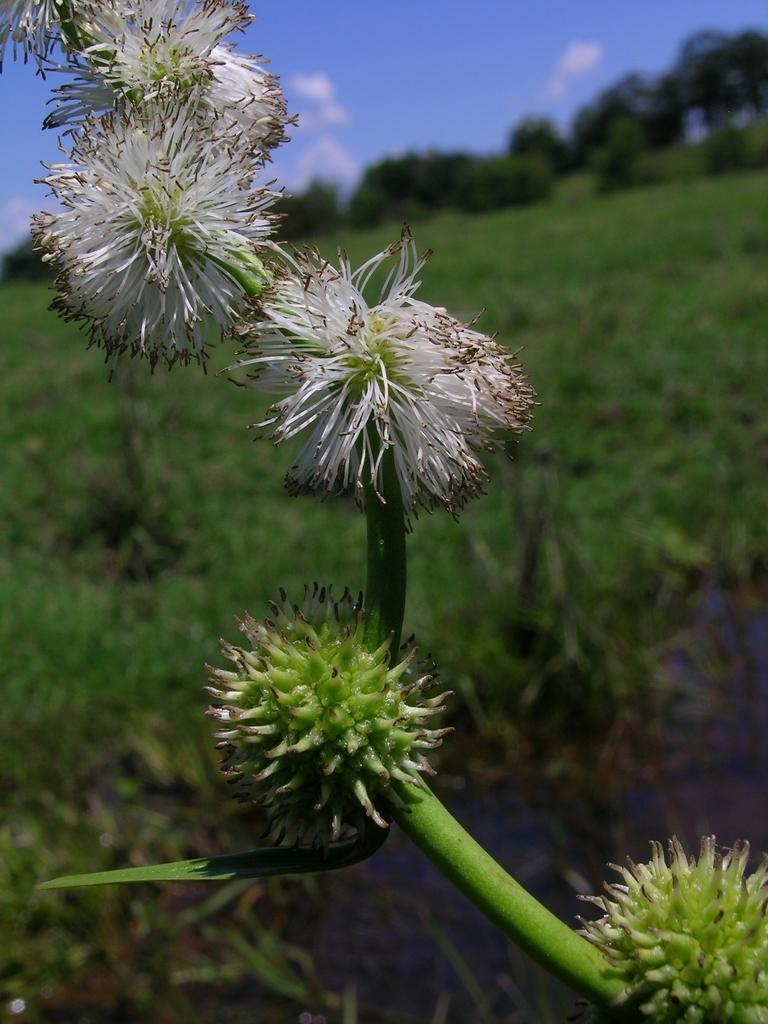Can you describe this image briefly? In this image we can see some flowers to the stem of a plant. On the backside we can see some plants, a group of trees and the sky which looks cloudy. 